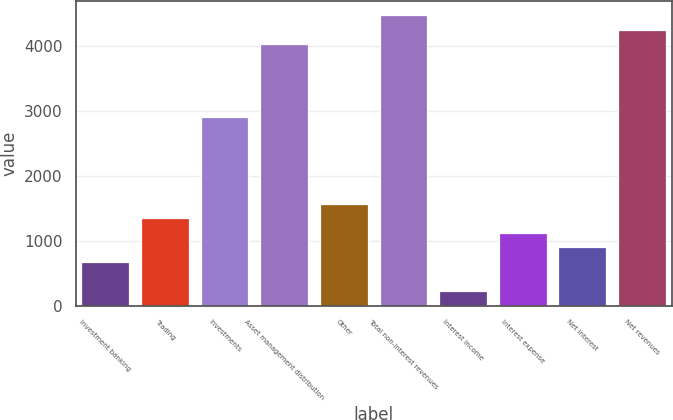Convert chart. <chart><loc_0><loc_0><loc_500><loc_500><bar_chart><fcel>Investment banking<fcel>Trading<fcel>Investments<fcel>Asset management distribution<fcel>Other<fcel>Total non-interest revenues<fcel>Interest income<fcel>Interest expense<fcel>Net interest<fcel>Net revenues<nl><fcel>679.2<fcel>1349.4<fcel>2913.2<fcel>4030.2<fcel>1572.8<fcel>4477<fcel>232.4<fcel>1126<fcel>902.6<fcel>4253.6<nl></chart> 